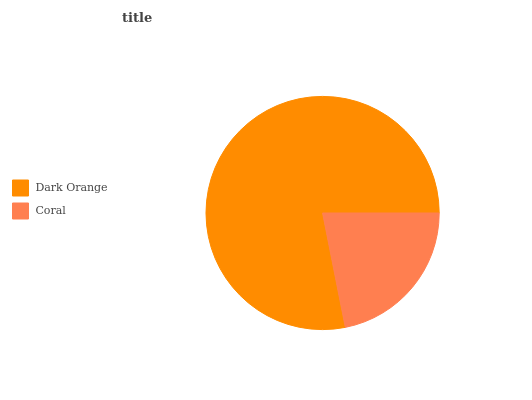Is Coral the minimum?
Answer yes or no. Yes. Is Dark Orange the maximum?
Answer yes or no. Yes. Is Coral the maximum?
Answer yes or no. No. Is Dark Orange greater than Coral?
Answer yes or no. Yes. Is Coral less than Dark Orange?
Answer yes or no. Yes. Is Coral greater than Dark Orange?
Answer yes or no. No. Is Dark Orange less than Coral?
Answer yes or no. No. Is Dark Orange the high median?
Answer yes or no. Yes. Is Coral the low median?
Answer yes or no. Yes. Is Coral the high median?
Answer yes or no. No. Is Dark Orange the low median?
Answer yes or no. No. 